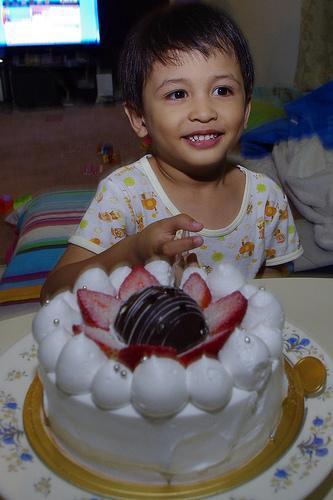How many strawberries are on the cake?
Give a very brief answer. 7. 